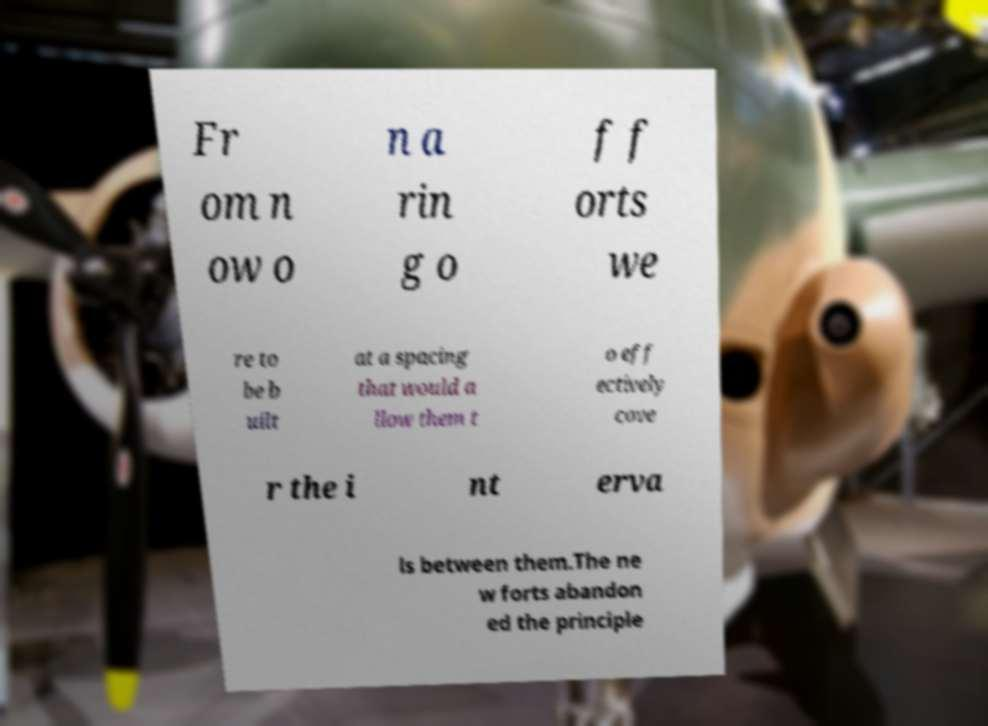Could you assist in decoding the text presented in this image and type it out clearly? Fr om n ow o n a rin g o f f orts we re to be b uilt at a spacing that would a llow them t o eff ectively cove r the i nt erva ls between them.The ne w forts abandon ed the principle 